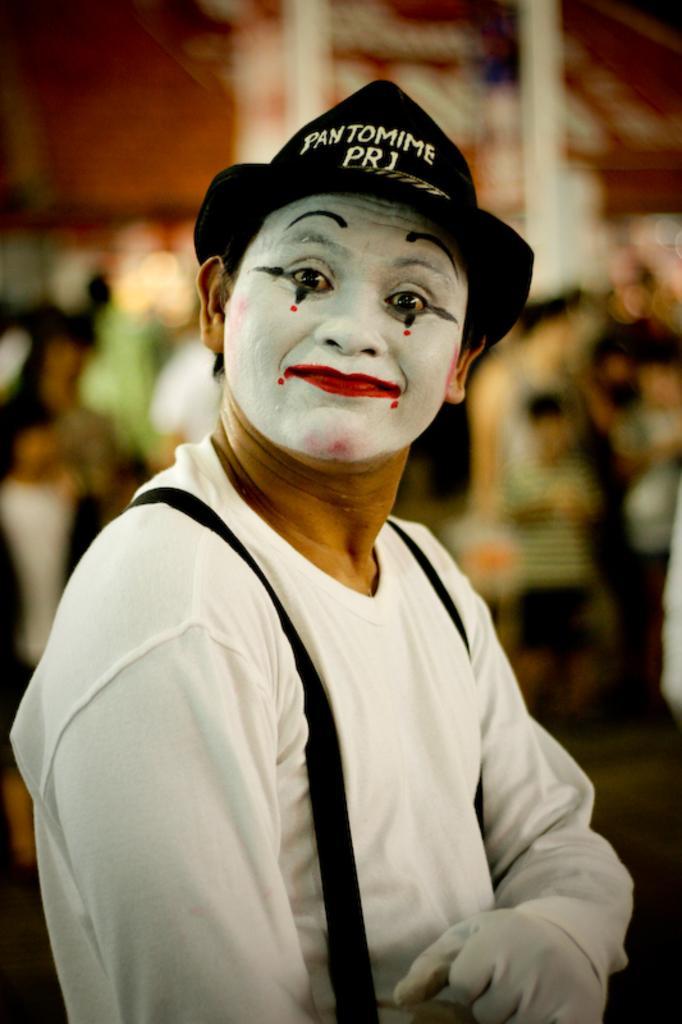Please provide a concise description of this image. In the picture we can see a person standing, he is with a white T-shirt and gloves and he is with a costume of a clown face and a black color hat and behind him we can see some people are standing are not clearly visible. 